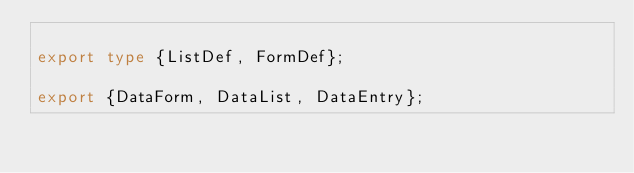<code> <loc_0><loc_0><loc_500><loc_500><_TypeScript_>
export type {ListDef, FormDef};

export {DataForm, DataList, DataEntry};
</code> 